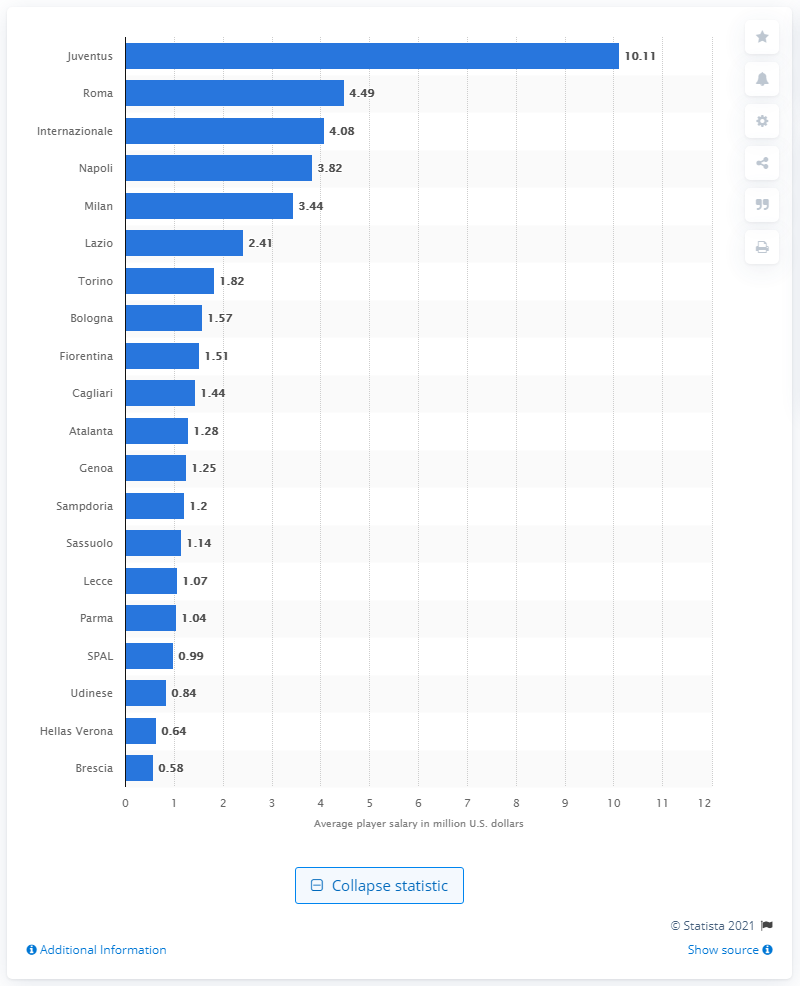Specify some key components in this picture. In the 2019/2020 season, Internazionale paid its players a total of 4.49 million US dollars. The average annual salary for Juventus players in the 2019/2020 season was 10.11. 